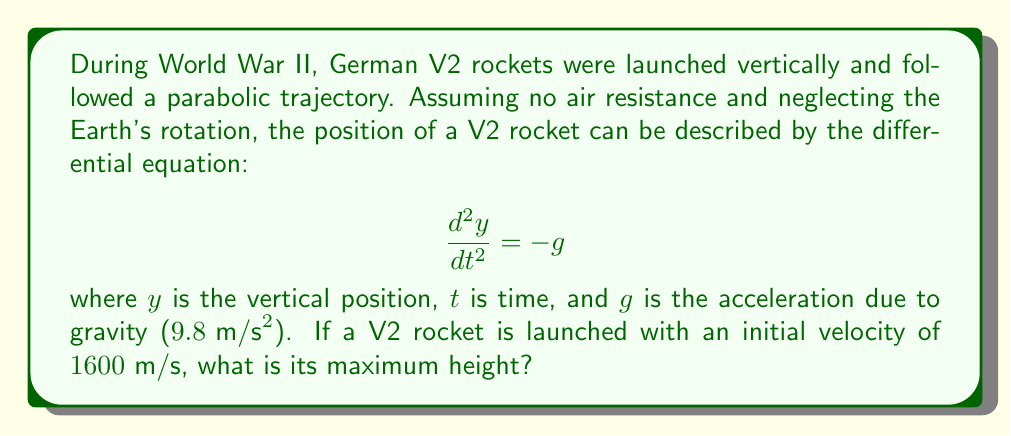Could you help me with this problem? To solve this problem, we'll follow these steps:

1) First, we need to integrate the differential equation twice to get the position function.

2) Integrating $\frac{d^2y}{dt^2} = -g$ once:

   $$\frac{dy}{dt} = -gt + C_1$$

   where $C_1$ is a constant of integration.

3) Integrating again:

   $$y = -\frac{1}{2}gt^2 + C_1t + C_2$$

   where $C_2$ is another constant of integration.

4) We can determine $C_1$ using the initial velocity. At $t=0$, $\frac{dy}{dt} = 1600$, so:

   $1600 = -g(0) + C_1$
   $C_1 = 1600$

5) We can determine $C_2$ using the initial position. At $t=0$, $y=0$, so:

   $0 = -\frac{1}{2}g(0)^2 + 1600(0) + C_2$
   $C_2 = 0$

6) Therefore, the position function is:

   $$y = -\frac{1}{2}gt^2 + 1600t$$

7) To find the maximum height, we need to find when the velocity is zero:

   $$\frac{dy}{dt} = -gt + 1600 = 0$$

   $$t = \frac{1600}{g} = \frac{1600}{9.8} \approx 163.27 \text{ seconds}$$

8) Plugging this time back into the position function:

   $$y_{max} = -\frac{1}{2}g(\frac{1600}{g})^2 + 1600(\frac{1600}{g})$$

   $$= -\frac{1600^2}{2g} + \frac{1600^2}{g} = \frac{1600^2}{2g}$$

9) Calculating the final result:

   $$y_{max} = \frac{1600^2}{2(9.8)} \approx 130,612 \text{ meters}$$
Answer: $130,612 \text{ meters}$ 